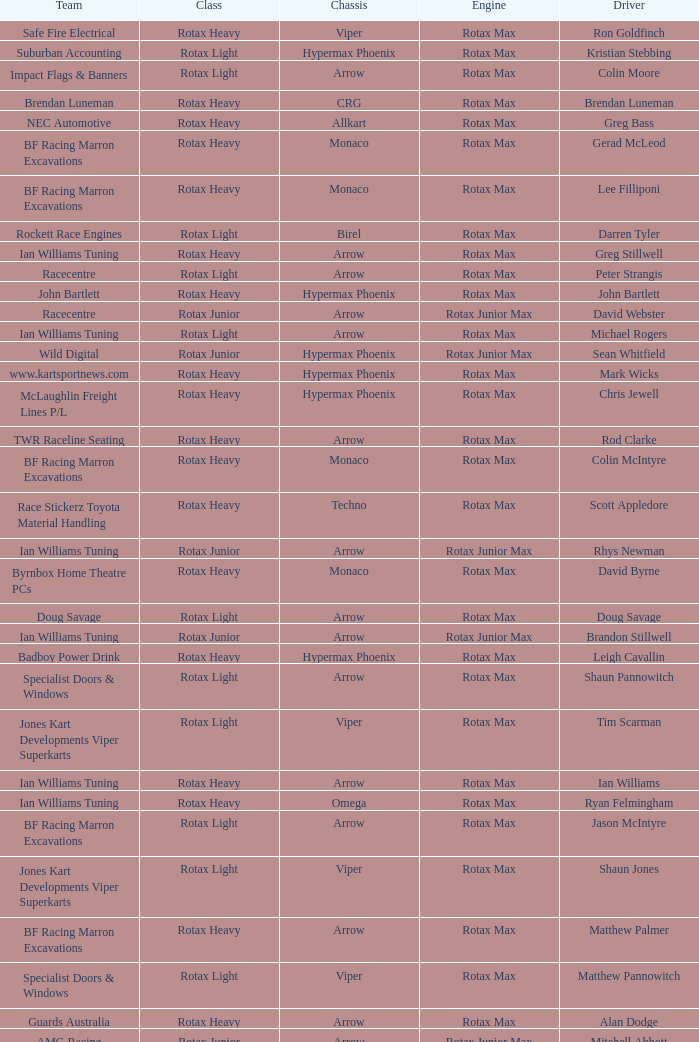What is the name of the team whose class is Rotax Light? Jones Kart Developments Viper Superkarts, Jones Kart Developments Viper Superkarts, BF Racing Marron Excavations, Ian Williams Tuning, Suburban Accounting, Suburban Accounting, Specialist Doors & Windows, Specialist Doors & Windows, Impact Flags & Banners, Rockett Race Engines, Racecentre, Doug Savage. 